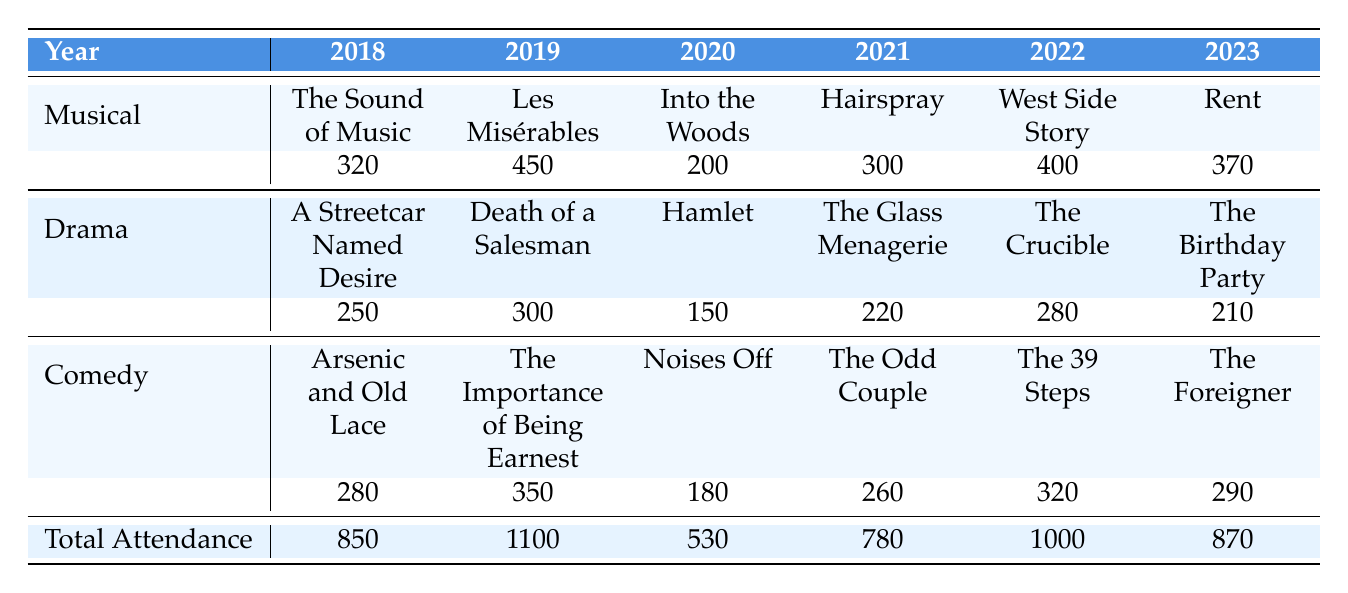What was the total attendance for musicals in 2022? The total attendance for musicals in 2022 is listed in the table under that year. It shows 400 for "West Side Story."
Answer: 400 Which year had the highest total attendance? The total attendance for each year is provided in the "Total Attendance" row. By comparing the values, 2019 has the highest total attendance with 1100.
Answer: 2019 Was the attendance for drama performances higher in 2021 or 2022? The attendance for drama performances is found under the respective years. In 2021 the attendance was 220, and in 2022 it was 280. Since 280 is greater than 220, 2022 had higher attendance.
Answer: 2022 What genre had the lowest attendance in 2020? The attendance for each genre in 2020 is listed. Musical had 200, Drama had 150, and Comedy had 180. Since 150 is the lowest, Drama had the lowest attendance.
Answer: Drama Calculate the average attendance for comedies across all years. The attendance figures for Comedy are 280, 350, 180, 260, 320, and 290. Adding these gives: 280 + 350 + 180 + 260 + 320 + 290 = 1680. Dividing by the number of years (6) gives: 1680 / 6 = 280.
Answer: 280 Did the attendance for musicals consistently increase from 2018 to 2023? Checking the musical attendance per year, it was 320 in 2018, then increased to 450 in 2019, dropped to 200 in 2020, rose to 300 in 2021, increased to 400 in 2022, and finally was 370 in 2023. Since there were decreases in 2020 and 2023, it did not consistently increase.
Answer: No Which genre had the highest single attendance count, and in what year? By looking through all the attendance counts for each genre, we see that the Musical "Les Misérables" in 2019 had the highest attendance of 450.
Answer: Musical, 2019 What was the change in total attendance from 2020 to 2021? Total attendance in 2020 was 530 and in 2021 was 780. The change can be calculated as 780 - 530 = 250.
Answer: 250 How many more attendees were there for comedy in 2022 compared to 2023? The attendance for Comedy in 2022 was 320 and in 2023 was 290. The difference is 320 - 290 = 30.
Answer: 30 Which year had the fewest attendees across all genres? By looking at the total attendance for each year, 2020 had the lowest value at 530.
Answer: 2020 